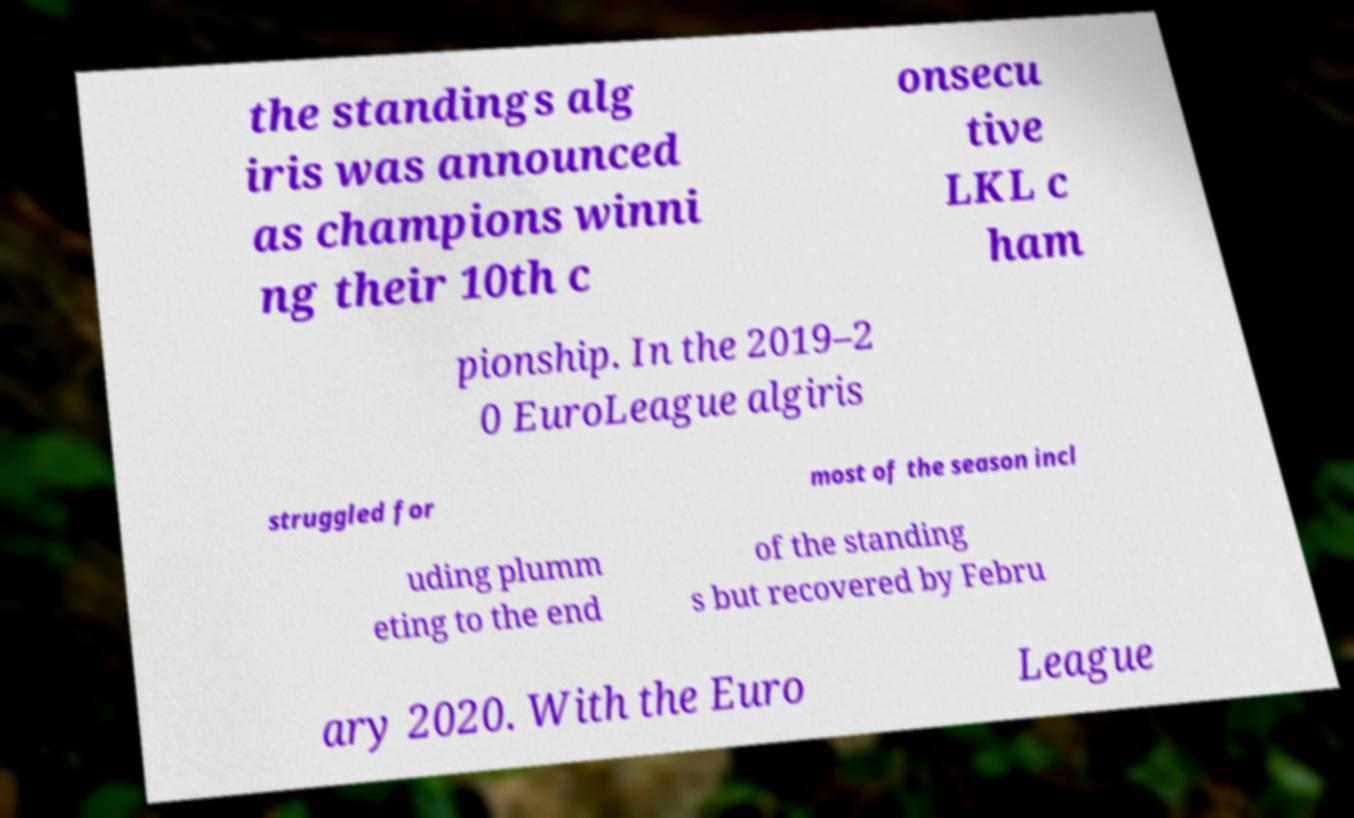Could you assist in decoding the text presented in this image and type it out clearly? the standings alg iris was announced as champions winni ng their 10th c onsecu tive LKL c ham pionship. In the 2019–2 0 EuroLeague algiris struggled for most of the season incl uding plumm eting to the end of the standing s but recovered by Febru ary 2020. With the Euro League 